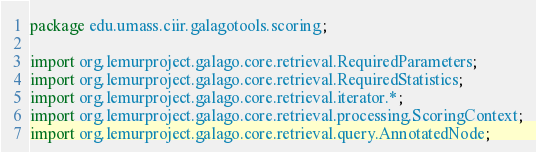<code> <loc_0><loc_0><loc_500><loc_500><_Java_>package edu.umass.ciir.galagotools.scoring;

import org.lemurproject.galago.core.retrieval.RequiredParameters;
import org.lemurproject.galago.core.retrieval.RequiredStatistics;
import org.lemurproject.galago.core.retrieval.iterator.*;
import org.lemurproject.galago.core.retrieval.processing.ScoringContext;
import org.lemurproject.galago.core.retrieval.query.AnnotatedNode;</code> 